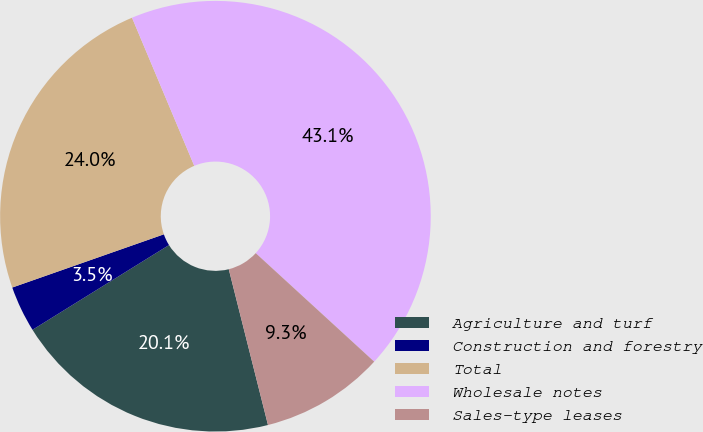Convert chart. <chart><loc_0><loc_0><loc_500><loc_500><pie_chart><fcel>Agriculture and turf<fcel>Construction and forestry<fcel>Total<fcel>Wholesale notes<fcel>Sales-type leases<nl><fcel>20.08%<fcel>3.47%<fcel>24.04%<fcel>43.13%<fcel>9.27%<nl></chart> 